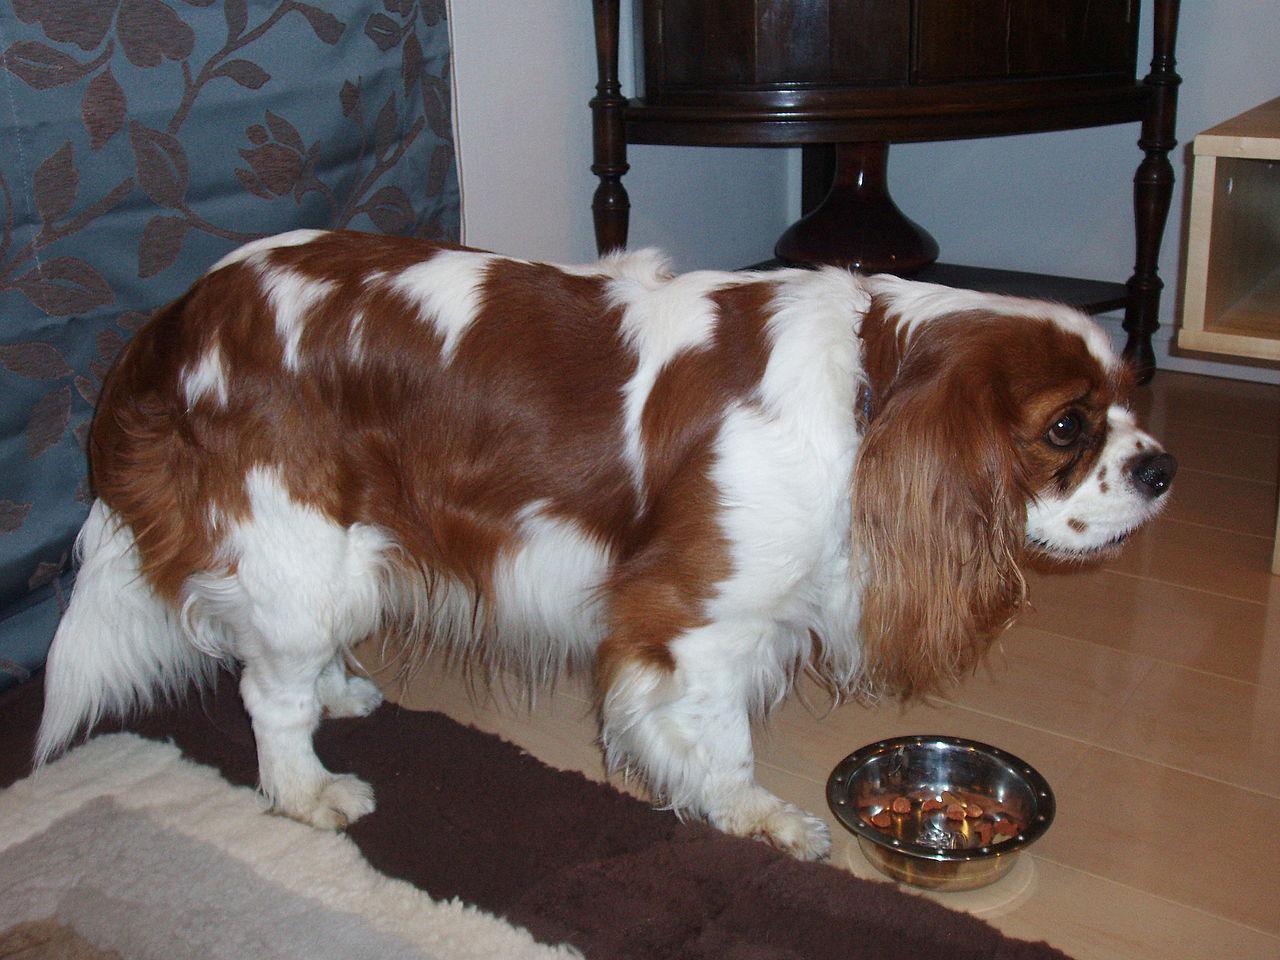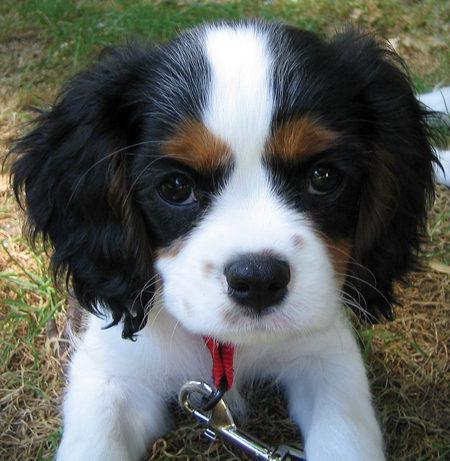The first image is the image on the left, the second image is the image on the right. Evaluate the accuracy of this statement regarding the images: "An image contains a dog attached to a leash.". Is it true? Answer yes or no. Yes. The first image is the image on the left, the second image is the image on the right. Examine the images to the left and right. Is the description "Right and left images contain the same number of spaniels, and all dogs are turned mostly frontward." accurate? Answer yes or no. No. 